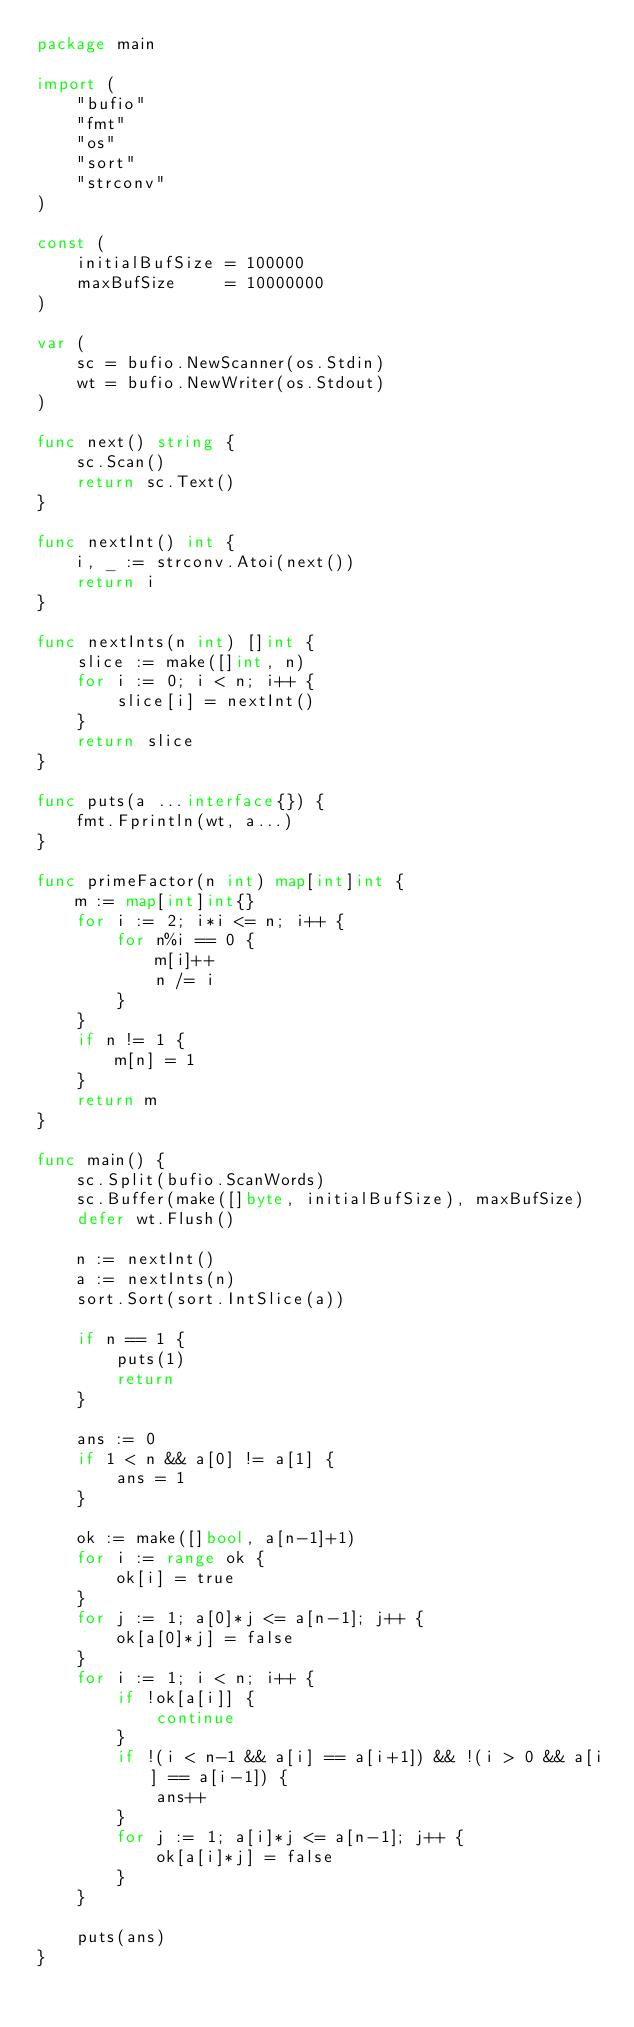<code> <loc_0><loc_0><loc_500><loc_500><_Go_>package main

import (
	"bufio"
	"fmt"
	"os"
	"sort"
	"strconv"
)

const (
	initialBufSize = 100000
	maxBufSize     = 10000000
)

var (
	sc = bufio.NewScanner(os.Stdin)
	wt = bufio.NewWriter(os.Stdout)
)

func next() string {
	sc.Scan()
	return sc.Text()
}

func nextInt() int {
	i, _ := strconv.Atoi(next())
	return i
}

func nextInts(n int) []int {
	slice := make([]int, n)
	for i := 0; i < n; i++ {
		slice[i] = nextInt()
	}
	return slice
}

func puts(a ...interface{}) {
	fmt.Fprintln(wt, a...)
}

func primeFactor(n int) map[int]int {
	m := map[int]int{}
	for i := 2; i*i <= n; i++ {
		for n%i == 0 {
			m[i]++
			n /= i
		}
	}
	if n != 1 {
		m[n] = 1
	}
	return m
}

func main() {
	sc.Split(bufio.ScanWords)
	sc.Buffer(make([]byte, initialBufSize), maxBufSize)
	defer wt.Flush()

	n := nextInt()
	a := nextInts(n)
	sort.Sort(sort.IntSlice(a))

	if n == 1 {
		puts(1)
		return
	}

	ans := 0
	if 1 < n && a[0] != a[1] {
		ans = 1
	}

	ok := make([]bool, a[n-1]+1)
	for i := range ok {
		ok[i] = true
	}
	for j := 1; a[0]*j <= a[n-1]; j++ {
		ok[a[0]*j] = false
	}
	for i := 1; i < n; i++ {
		if !ok[a[i]] {
			continue
		}
		if !(i < n-1 && a[i] == a[i+1]) && !(i > 0 && a[i] == a[i-1]) {
			ans++
		}
		for j := 1; a[i]*j <= a[n-1]; j++ {
			ok[a[i]*j] = false
		}
	}

	puts(ans)
}
</code> 